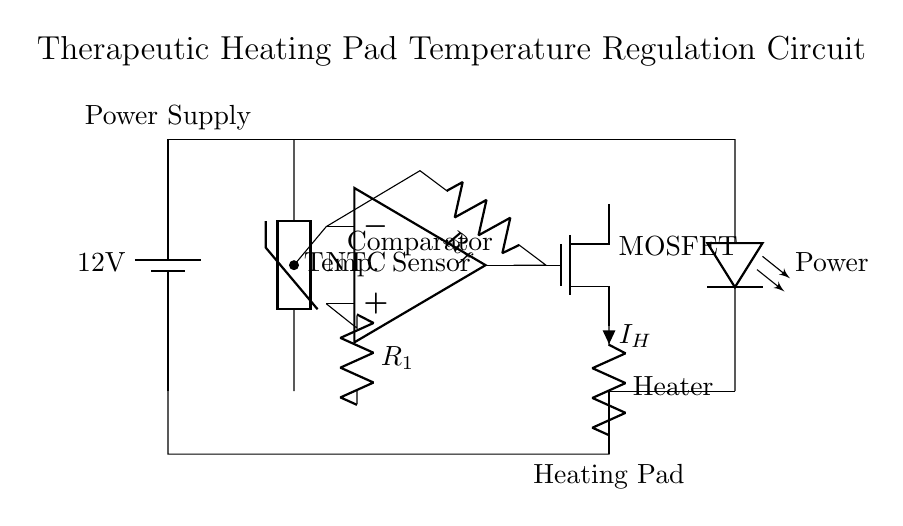What is the voltage of this circuit? The voltage is 12 volts, as indicated by the battery symbol at the top left of the diagram, which shows a power supply of 12 volts.
Answer: 12 volts What type of temperature sensor is used? The temperature sensor is a thermistor, specifically noted as NTC (Negative Temperature Coefficient), which is visible in the diagram labeled at the second element from the left.
Answer: NTC What role does the operational amplifier serve in this circuit? The operational amplifier acts as a comparator, which is confirmed by its labeling in the circuit and its connection to both the thermistor and the feedback resistor. It compares the input from the thermistor with a reference to control the MOSFET.
Answer: Comparator What does the feedback resistor do? The feedback resistor connects from the output of the operational amplifier back to its inverting input, allowing it to stabilize the output and set the gain of the comparator function based on the circuit's requirements.
Answer: Stabilizes output What component controls the heating element? The heating element is controlled by the MOSFET, as shown in the circuit; it receives the signal from the operational amplifier to allow or block current flow to the heating pad.
Answer: MOSFET What indicates when the circuit is powered on? The power indicator is an LED, labeled clearly in the circuit diagram, which lights up when there is current flowing from the power supply, providing a visual cue that the circuit is operational.
Answer: LED How does the current flow to the heating element? The current flows from the source of the MOSFET through the heating element labeled as Heater, then back to the power supply, completing the circuit as noted by the connections drawn.
Answer: Through the MOSFET 